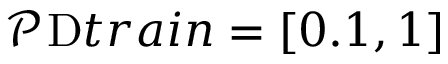Convert formula to latex. <formula><loc_0><loc_0><loc_500><loc_500>\mathcal { P } t r a i n = [ 0 . 1 , 1 ]</formula> 